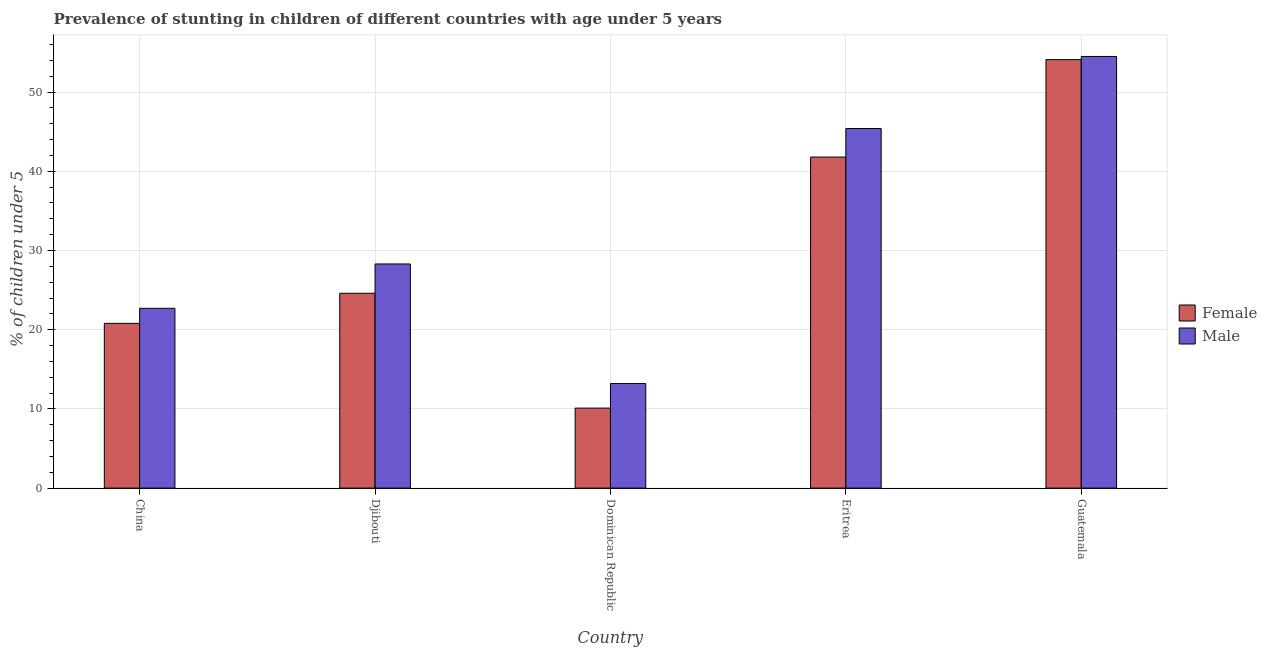How many groups of bars are there?
Your answer should be very brief. 5. Are the number of bars per tick equal to the number of legend labels?
Your answer should be compact. Yes. What is the label of the 1st group of bars from the left?
Offer a terse response. China. In how many cases, is the number of bars for a given country not equal to the number of legend labels?
Keep it short and to the point. 0. What is the percentage of stunted female children in Djibouti?
Provide a succinct answer. 24.6. Across all countries, what is the maximum percentage of stunted female children?
Ensure brevity in your answer.  54.1. Across all countries, what is the minimum percentage of stunted male children?
Offer a very short reply. 13.2. In which country was the percentage of stunted female children maximum?
Provide a short and direct response. Guatemala. In which country was the percentage of stunted female children minimum?
Provide a short and direct response. Dominican Republic. What is the total percentage of stunted female children in the graph?
Keep it short and to the point. 151.4. What is the difference between the percentage of stunted male children in Djibouti and that in Guatemala?
Your response must be concise. -26.2. What is the difference between the percentage of stunted male children in Eritrea and the percentage of stunted female children in Dominican Republic?
Provide a succinct answer. 35.3. What is the average percentage of stunted male children per country?
Your answer should be very brief. 32.82. What is the difference between the percentage of stunted female children and percentage of stunted male children in Djibouti?
Provide a short and direct response. -3.7. In how many countries, is the percentage of stunted female children greater than 20 %?
Your response must be concise. 4. What is the ratio of the percentage of stunted male children in China to that in Guatemala?
Provide a short and direct response. 0.42. Is the difference between the percentage of stunted male children in Dominican Republic and Eritrea greater than the difference between the percentage of stunted female children in Dominican Republic and Eritrea?
Your answer should be compact. No. What is the difference between the highest and the second highest percentage of stunted male children?
Your answer should be compact. 9.1. What is the difference between the highest and the lowest percentage of stunted male children?
Offer a terse response. 41.3. Is the sum of the percentage of stunted male children in Dominican Republic and Guatemala greater than the maximum percentage of stunted female children across all countries?
Offer a very short reply. Yes. How many bars are there?
Your answer should be compact. 10. Are all the bars in the graph horizontal?
Offer a terse response. No. How many countries are there in the graph?
Make the answer very short. 5. Does the graph contain any zero values?
Make the answer very short. No. Where does the legend appear in the graph?
Keep it short and to the point. Center right. How many legend labels are there?
Your answer should be compact. 2. What is the title of the graph?
Your response must be concise. Prevalence of stunting in children of different countries with age under 5 years. Does "% of GNI" appear as one of the legend labels in the graph?
Offer a very short reply. No. What is the label or title of the Y-axis?
Offer a very short reply.  % of children under 5. What is the  % of children under 5 of Female in China?
Keep it short and to the point. 20.8. What is the  % of children under 5 in Male in China?
Offer a very short reply. 22.7. What is the  % of children under 5 of Female in Djibouti?
Ensure brevity in your answer.  24.6. What is the  % of children under 5 of Male in Djibouti?
Provide a short and direct response. 28.3. What is the  % of children under 5 of Female in Dominican Republic?
Your answer should be very brief. 10.1. What is the  % of children under 5 of Male in Dominican Republic?
Offer a very short reply. 13.2. What is the  % of children under 5 in Female in Eritrea?
Your response must be concise. 41.8. What is the  % of children under 5 in Male in Eritrea?
Offer a terse response. 45.4. What is the  % of children under 5 of Female in Guatemala?
Keep it short and to the point. 54.1. What is the  % of children under 5 in Male in Guatemala?
Your answer should be compact. 54.5. Across all countries, what is the maximum  % of children under 5 in Female?
Offer a very short reply. 54.1. Across all countries, what is the maximum  % of children under 5 in Male?
Make the answer very short. 54.5. Across all countries, what is the minimum  % of children under 5 in Female?
Offer a very short reply. 10.1. Across all countries, what is the minimum  % of children under 5 in Male?
Keep it short and to the point. 13.2. What is the total  % of children under 5 of Female in the graph?
Your answer should be compact. 151.4. What is the total  % of children under 5 in Male in the graph?
Give a very brief answer. 164.1. What is the difference between the  % of children under 5 in Male in China and that in Djibouti?
Provide a short and direct response. -5.6. What is the difference between the  % of children under 5 in Female in China and that in Dominican Republic?
Your answer should be compact. 10.7. What is the difference between the  % of children under 5 of Male in China and that in Eritrea?
Offer a terse response. -22.7. What is the difference between the  % of children under 5 of Female in China and that in Guatemala?
Give a very brief answer. -33.3. What is the difference between the  % of children under 5 in Male in China and that in Guatemala?
Your answer should be compact. -31.8. What is the difference between the  % of children under 5 in Female in Djibouti and that in Eritrea?
Offer a terse response. -17.2. What is the difference between the  % of children under 5 of Male in Djibouti and that in Eritrea?
Your answer should be very brief. -17.1. What is the difference between the  % of children under 5 in Female in Djibouti and that in Guatemala?
Give a very brief answer. -29.5. What is the difference between the  % of children under 5 of Male in Djibouti and that in Guatemala?
Your answer should be very brief. -26.2. What is the difference between the  % of children under 5 of Female in Dominican Republic and that in Eritrea?
Offer a very short reply. -31.7. What is the difference between the  % of children under 5 of Male in Dominican Republic and that in Eritrea?
Offer a very short reply. -32.2. What is the difference between the  % of children under 5 in Female in Dominican Republic and that in Guatemala?
Make the answer very short. -44. What is the difference between the  % of children under 5 in Male in Dominican Republic and that in Guatemala?
Provide a succinct answer. -41.3. What is the difference between the  % of children under 5 in Female in Eritrea and that in Guatemala?
Offer a terse response. -12.3. What is the difference between the  % of children under 5 of Female in China and the  % of children under 5 of Male in Djibouti?
Provide a short and direct response. -7.5. What is the difference between the  % of children under 5 in Female in China and the  % of children under 5 in Male in Eritrea?
Make the answer very short. -24.6. What is the difference between the  % of children under 5 in Female in China and the  % of children under 5 in Male in Guatemala?
Provide a short and direct response. -33.7. What is the difference between the  % of children under 5 in Female in Djibouti and the  % of children under 5 in Male in Eritrea?
Give a very brief answer. -20.8. What is the difference between the  % of children under 5 of Female in Djibouti and the  % of children under 5 of Male in Guatemala?
Give a very brief answer. -29.9. What is the difference between the  % of children under 5 of Female in Dominican Republic and the  % of children under 5 of Male in Eritrea?
Offer a terse response. -35.3. What is the difference between the  % of children under 5 of Female in Dominican Republic and the  % of children under 5 of Male in Guatemala?
Provide a short and direct response. -44.4. What is the average  % of children under 5 in Female per country?
Your answer should be compact. 30.28. What is the average  % of children under 5 of Male per country?
Keep it short and to the point. 32.82. What is the difference between the  % of children under 5 of Female and  % of children under 5 of Male in Djibouti?
Offer a very short reply. -3.7. What is the difference between the  % of children under 5 of Female and  % of children under 5 of Male in Dominican Republic?
Your answer should be very brief. -3.1. What is the difference between the  % of children under 5 of Female and  % of children under 5 of Male in Guatemala?
Give a very brief answer. -0.4. What is the ratio of the  % of children under 5 of Female in China to that in Djibouti?
Ensure brevity in your answer.  0.85. What is the ratio of the  % of children under 5 of Male in China to that in Djibouti?
Provide a succinct answer. 0.8. What is the ratio of the  % of children under 5 of Female in China to that in Dominican Republic?
Give a very brief answer. 2.06. What is the ratio of the  % of children under 5 in Male in China to that in Dominican Republic?
Offer a very short reply. 1.72. What is the ratio of the  % of children under 5 in Female in China to that in Eritrea?
Keep it short and to the point. 0.5. What is the ratio of the  % of children under 5 in Female in China to that in Guatemala?
Your response must be concise. 0.38. What is the ratio of the  % of children under 5 in Male in China to that in Guatemala?
Your response must be concise. 0.42. What is the ratio of the  % of children under 5 of Female in Djibouti to that in Dominican Republic?
Ensure brevity in your answer.  2.44. What is the ratio of the  % of children under 5 of Male in Djibouti to that in Dominican Republic?
Your answer should be very brief. 2.14. What is the ratio of the  % of children under 5 in Female in Djibouti to that in Eritrea?
Ensure brevity in your answer.  0.59. What is the ratio of the  % of children under 5 in Male in Djibouti to that in Eritrea?
Your answer should be very brief. 0.62. What is the ratio of the  % of children under 5 in Female in Djibouti to that in Guatemala?
Make the answer very short. 0.45. What is the ratio of the  % of children under 5 of Male in Djibouti to that in Guatemala?
Your answer should be very brief. 0.52. What is the ratio of the  % of children under 5 of Female in Dominican Republic to that in Eritrea?
Provide a succinct answer. 0.24. What is the ratio of the  % of children under 5 of Male in Dominican Republic to that in Eritrea?
Offer a very short reply. 0.29. What is the ratio of the  % of children under 5 in Female in Dominican Republic to that in Guatemala?
Your response must be concise. 0.19. What is the ratio of the  % of children under 5 in Male in Dominican Republic to that in Guatemala?
Your response must be concise. 0.24. What is the ratio of the  % of children under 5 in Female in Eritrea to that in Guatemala?
Your answer should be compact. 0.77. What is the ratio of the  % of children under 5 in Male in Eritrea to that in Guatemala?
Provide a short and direct response. 0.83. What is the difference between the highest and the lowest  % of children under 5 in Male?
Offer a very short reply. 41.3. 